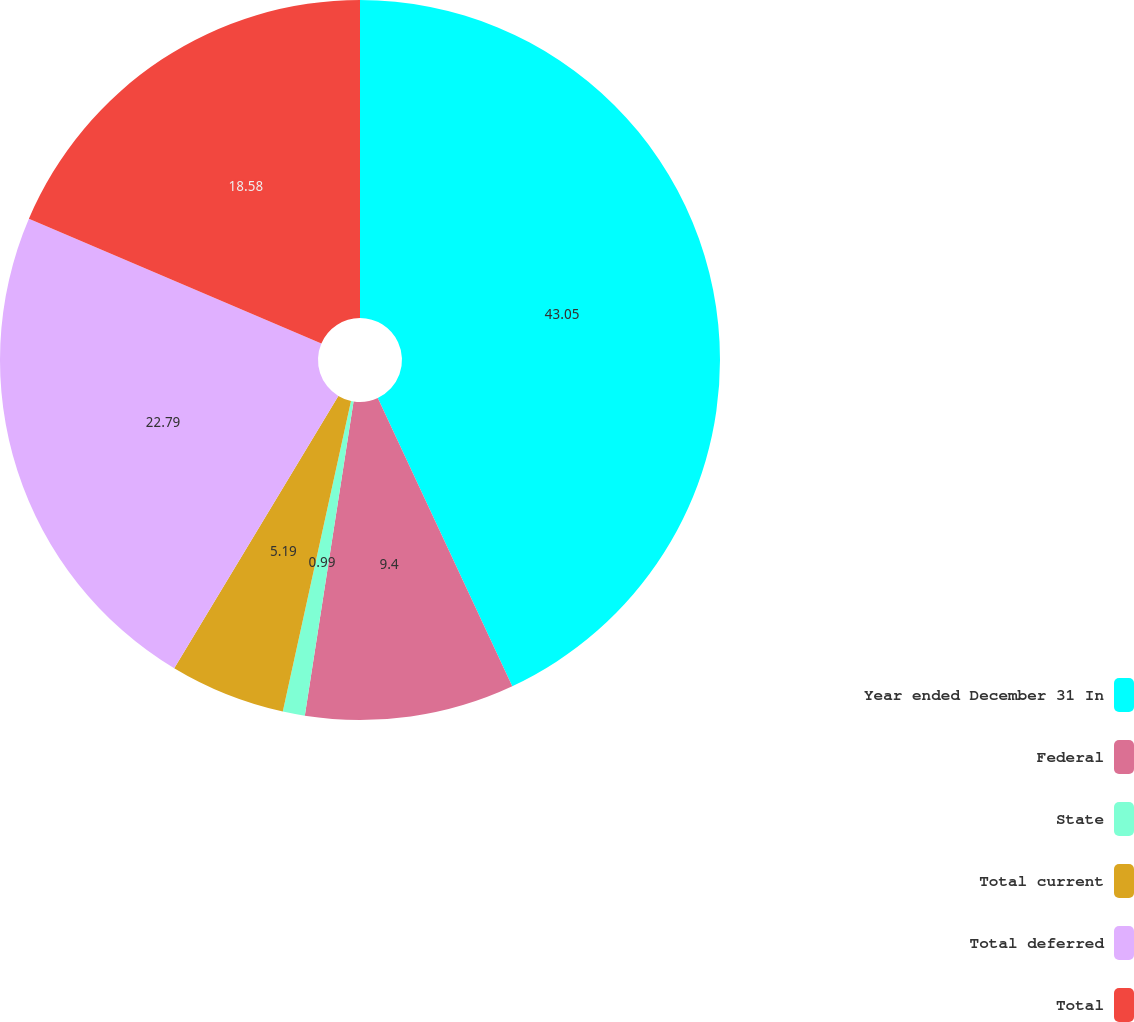Convert chart to OTSL. <chart><loc_0><loc_0><loc_500><loc_500><pie_chart><fcel>Year ended December 31 In<fcel>Federal<fcel>State<fcel>Total current<fcel>Total deferred<fcel>Total<nl><fcel>43.05%<fcel>9.4%<fcel>0.99%<fcel>5.19%<fcel>22.79%<fcel>18.58%<nl></chart> 